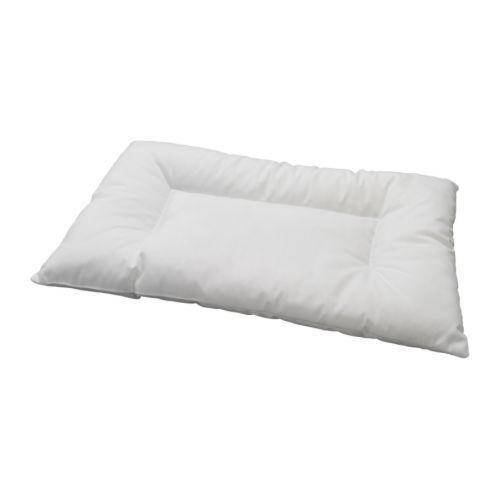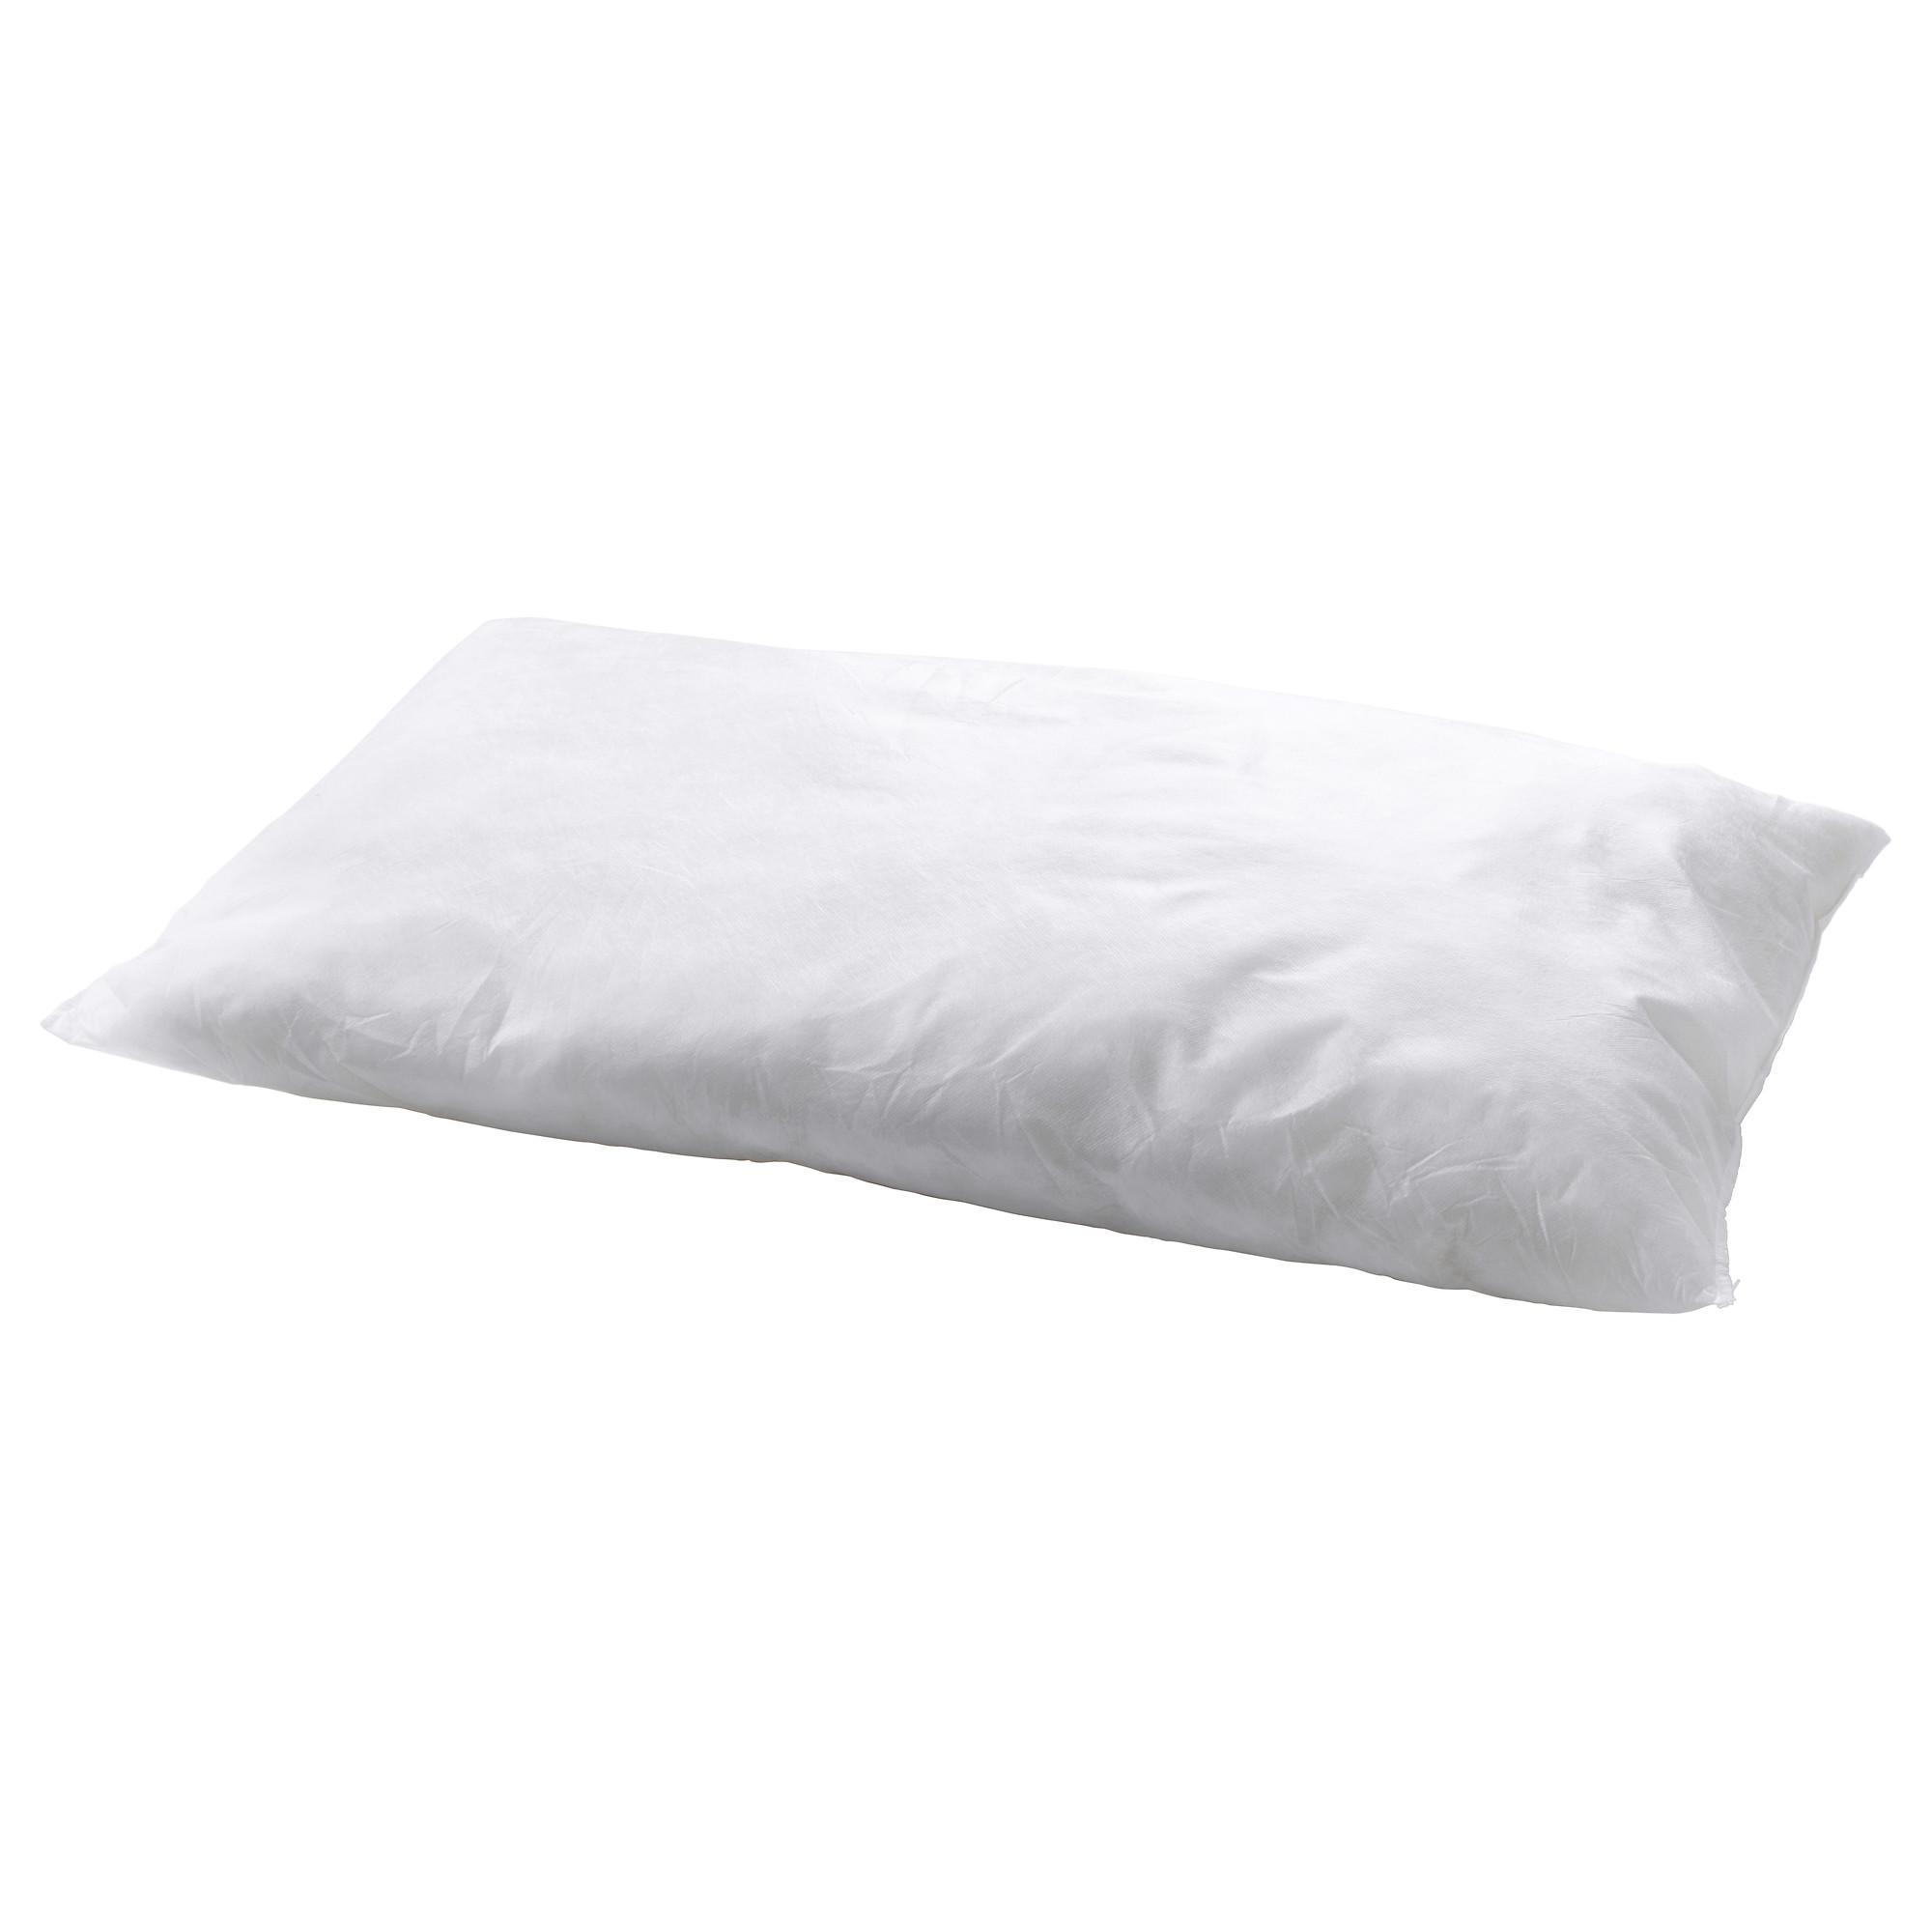The first image is the image on the left, the second image is the image on the right. Analyze the images presented: Is the assertion "There are three or more white pillows that are resting on white mattresses." valid? Answer yes or no. No. The first image is the image on the left, the second image is the image on the right. For the images shown, is this caption "There are three or fewer pillows." true? Answer yes or no. Yes. 